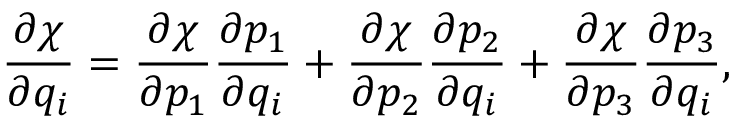Convert formula to latex. <formula><loc_0><loc_0><loc_500><loc_500>\frac { \partial \chi } { \partial q _ { i } } = \frac { \partial \chi } { \partial p _ { 1 } } \frac { \partial p _ { 1 } } { \partial q _ { i } } + \frac { \partial \chi } { \partial p _ { 2 } } \frac { \partial p _ { 2 } } { \partial q _ { i } } + \frac { \partial \chi } { \partial p _ { 3 } } \frac { \partial p _ { 3 } } { \partial q _ { i } } ,</formula> 